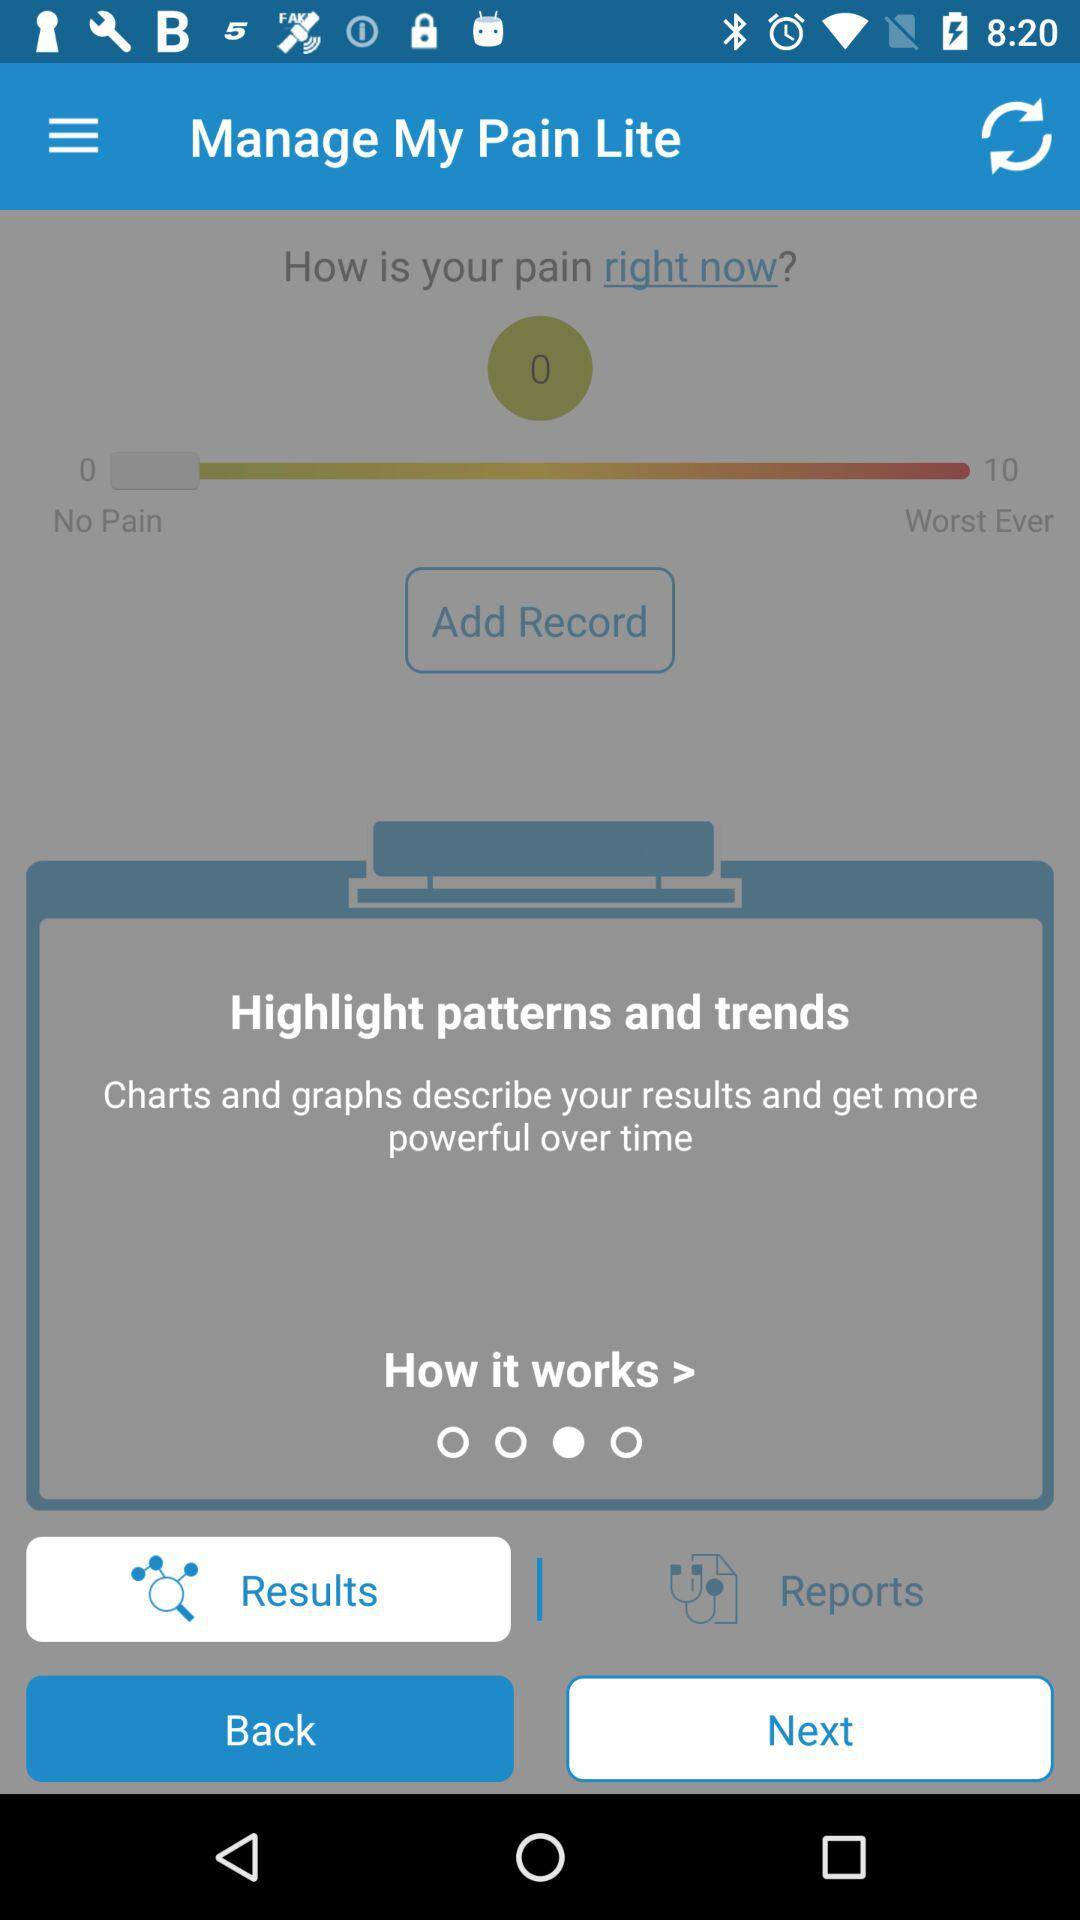What is the difference between the highest and lowest pain levels?
Answer the question using a single word or phrase. 10 